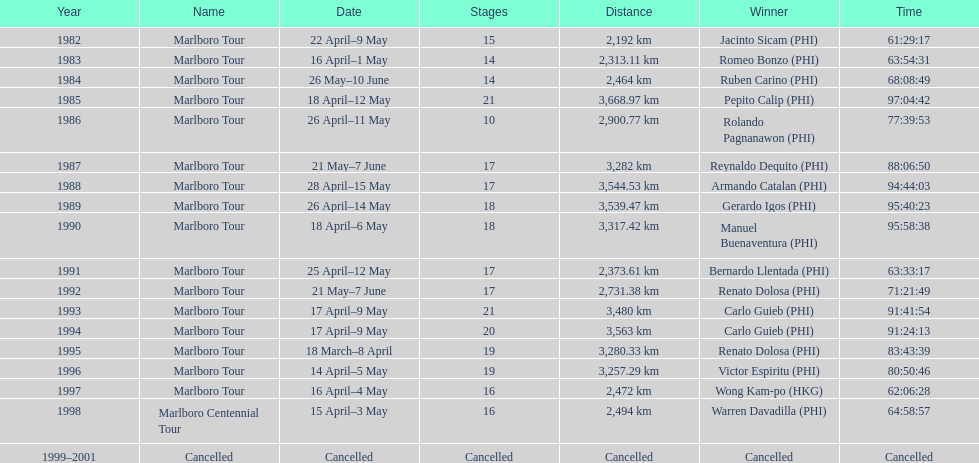Who is cited before wong kam-po? Victor Espiritu (PHI). 